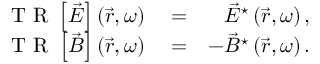Convert formula to latex. <formula><loc_0><loc_0><loc_500><loc_500>\begin{array} { r l r } { T R \left [ \vec { E } \right ] \left ( \vec { r } , \omega \right ) } & = } & { \vec { E } ^ { ^ { * } } \left ( \vec { r } , \omega \right ) , } \\ { T R \left [ \vec { B } \right ] \left ( \vec { r } , \omega \right ) } & = } & { - \vec { B } ^ { ^ { * } } \left ( \vec { r } , \omega \right ) . } \end{array}</formula> 